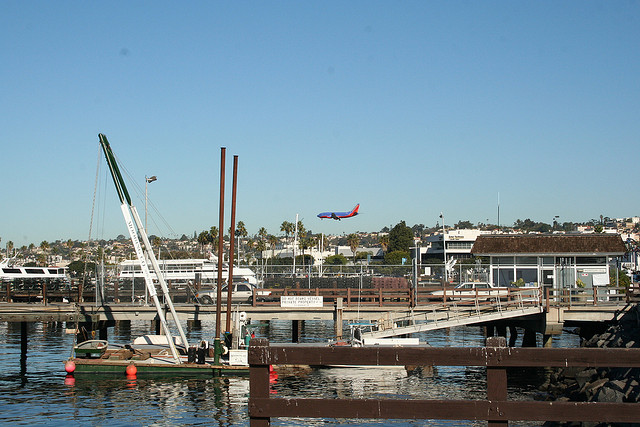What is soaring through the air? In the provided image, there is an airplane soaring through the air, distinguishable by its characteristic shape, including the fuselage and wings, and the fact that it's in the sky, which is a common flight path for airplanes. 